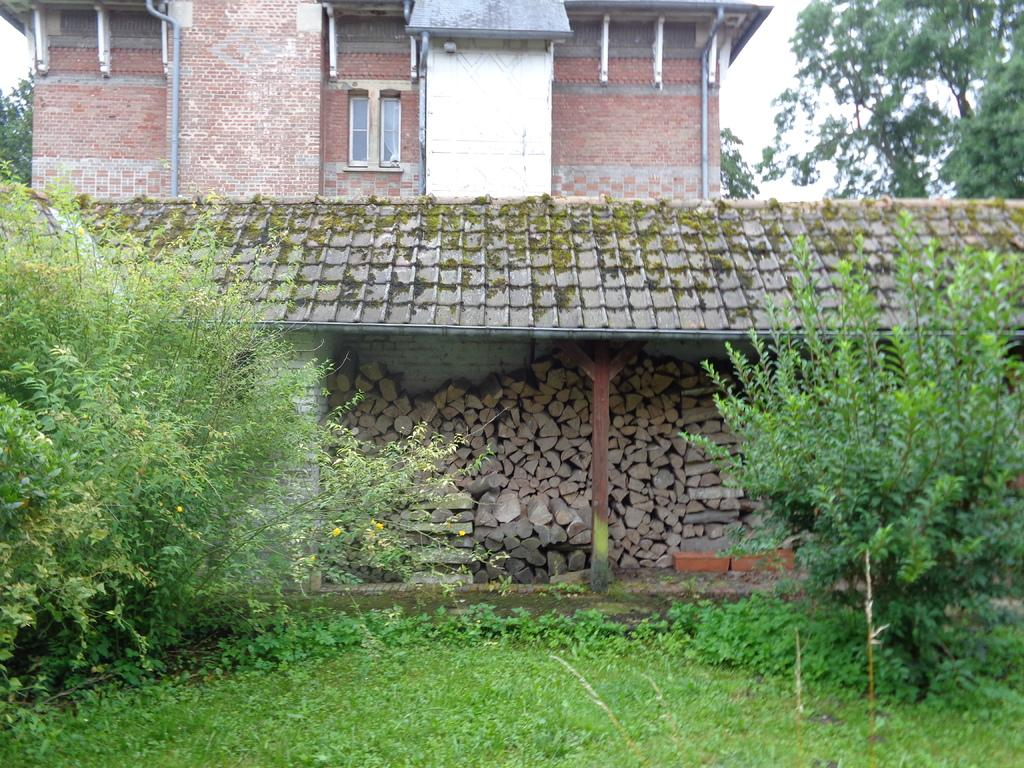What type of natural elements can be seen in the image? There are plants and trees visible in the image. What man-made structures can be seen in the image? There is a building with windows, pipes, a roof, pillars, and walls visible in the image. What materials are used for the structures in the image? Wooden logs and metal pipes are used for the structures in the image. What is visible in the background of the image? The sky is visible in the background of the image. How many planes are parked on the shelf in the image? There is no shelf or planes present in the image. What type of ship can be seen sailing in the background of the image? There is no ship visible in the image; only the sky is visible in the background. 